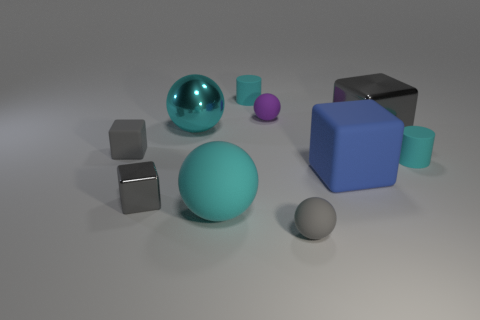Subtract all purple balls. How many gray blocks are left? 3 Subtract all rubber spheres. How many spheres are left? 1 Subtract 1 spheres. How many spheres are left? 3 Subtract all green cubes. Subtract all yellow cylinders. How many cubes are left? 4 Subtract all cylinders. How many objects are left? 8 Add 3 big blue blocks. How many big blue blocks are left? 4 Add 5 big spheres. How many big spheres exist? 7 Subtract 2 cyan balls. How many objects are left? 8 Subtract all brown spheres. Subtract all big gray blocks. How many objects are left? 9 